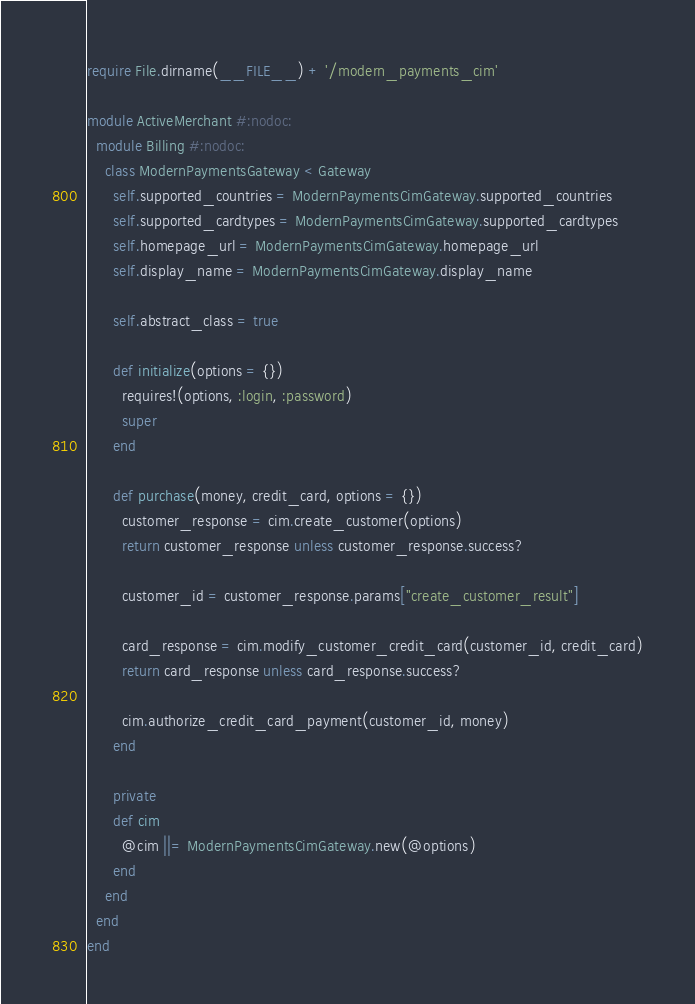<code> <loc_0><loc_0><loc_500><loc_500><_Ruby_>require File.dirname(__FILE__) + '/modern_payments_cim'

module ActiveMerchant #:nodoc:
  module Billing #:nodoc:
    class ModernPaymentsGateway < Gateway
      self.supported_countries = ModernPaymentsCimGateway.supported_countries
      self.supported_cardtypes = ModernPaymentsCimGateway.supported_cardtypes
      self.homepage_url = ModernPaymentsCimGateway.homepage_url
      self.display_name = ModernPaymentsCimGateway.display_name

      self.abstract_class = true

      def initialize(options = {})
        requires!(options, :login, :password)
        super
      end

      def purchase(money, credit_card, options = {})
        customer_response = cim.create_customer(options)
        return customer_response unless customer_response.success?

        customer_id = customer_response.params["create_customer_result"]

        card_response = cim.modify_customer_credit_card(customer_id, credit_card)
        return card_response unless card_response.success?

        cim.authorize_credit_card_payment(customer_id, money)
      end

      private
      def cim
        @cim ||= ModernPaymentsCimGateway.new(@options)
      end
    end
  end
end

</code> 